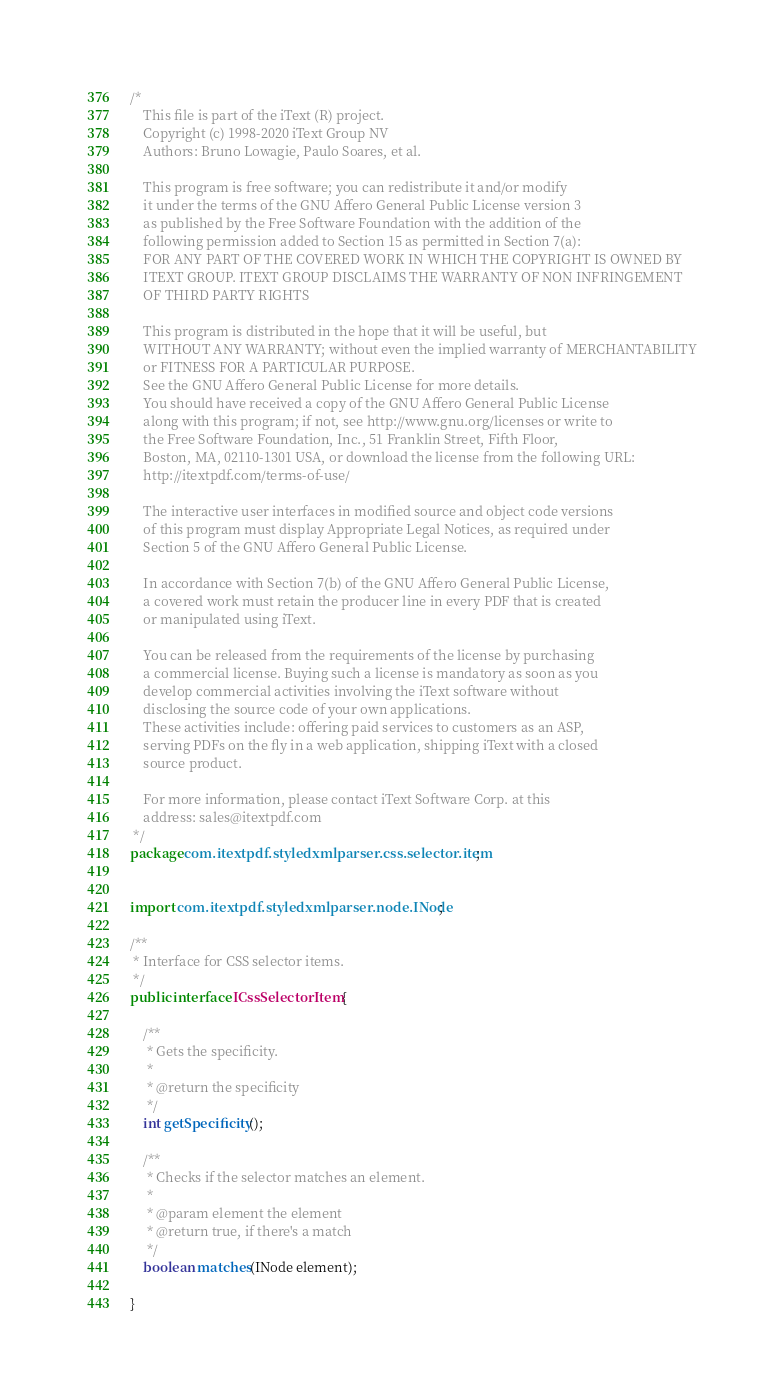Convert code to text. <code><loc_0><loc_0><loc_500><loc_500><_Java_>/*
    This file is part of the iText (R) project.
    Copyright (c) 1998-2020 iText Group NV
    Authors: Bruno Lowagie, Paulo Soares, et al.
    
    This program is free software; you can redistribute it and/or modify
    it under the terms of the GNU Affero General Public License version 3
    as published by the Free Software Foundation with the addition of the
    following permission added to Section 15 as permitted in Section 7(a):
    FOR ANY PART OF THE COVERED WORK IN WHICH THE COPYRIGHT IS OWNED BY
    ITEXT GROUP. ITEXT GROUP DISCLAIMS THE WARRANTY OF NON INFRINGEMENT
    OF THIRD PARTY RIGHTS
    
    This program is distributed in the hope that it will be useful, but
    WITHOUT ANY WARRANTY; without even the implied warranty of MERCHANTABILITY
    or FITNESS FOR A PARTICULAR PURPOSE.
    See the GNU Affero General Public License for more details.
    You should have received a copy of the GNU Affero General Public License
    along with this program; if not, see http://www.gnu.org/licenses or write to
    the Free Software Foundation, Inc., 51 Franklin Street, Fifth Floor,
    Boston, MA, 02110-1301 USA, or download the license from the following URL:
    http://itextpdf.com/terms-of-use/
    
    The interactive user interfaces in modified source and object code versions
    of this program must display Appropriate Legal Notices, as required under
    Section 5 of the GNU Affero General Public License.
    
    In accordance with Section 7(b) of the GNU Affero General Public License,
    a covered work must retain the producer line in every PDF that is created
    or manipulated using iText.
    
    You can be released from the requirements of the license by purchasing
    a commercial license. Buying such a license is mandatory as soon as you
    develop commercial activities involving the iText software without
    disclosing the source code of your own applications.
    These activities include: offering paid services to customers as an ASP,
    serving PDFs on the fly in a web application, shipping iText with a closed
    source product.
    
    For more information, please contact iText Software Corp. at this
    address: sales@itextpdf.com
 */
package com.itextpdf.styledxmlparser.css.selector.item;


import com.itextpdf.styledxmlparser.node.INode;

/**
 * Interface for CSS selector items.
 */
public interface ICssSelectorItem {

    /**
     * Gets the specificity.
     *
     * @return the specificity
     */
    int getSpecificity();

    /**
     * Checks if the selector matches an element.
     *
     * @param element the element
     * @return true, if there's a match
     */
    boolean matches(INode element);

}
</code> 